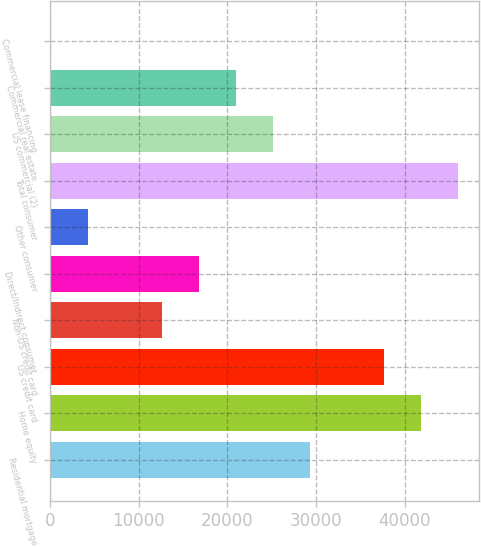<chart> <loc_0><loc_0><loc_500><loc_500><bar_chart><fcel>Residential mortgage<fcel>Home equity<fcel>US credit card<fcel>Non-US credit card<fcel>Direct/Indirect consumer<fcel>Other consumer<fcel>Total consumer<fcel>US commercial (2)<fcel>Commercial real estate<fcel>Commercial lease financing<nl><fcel>29357.3<fcel>41885<fcel>37709.1<fcel>12653.7<fcel>16829.6<fcel>4301.9<fcel>46060.9<fcel>25181.4<fcel>21005.5<fcel>126<nl></chart> 